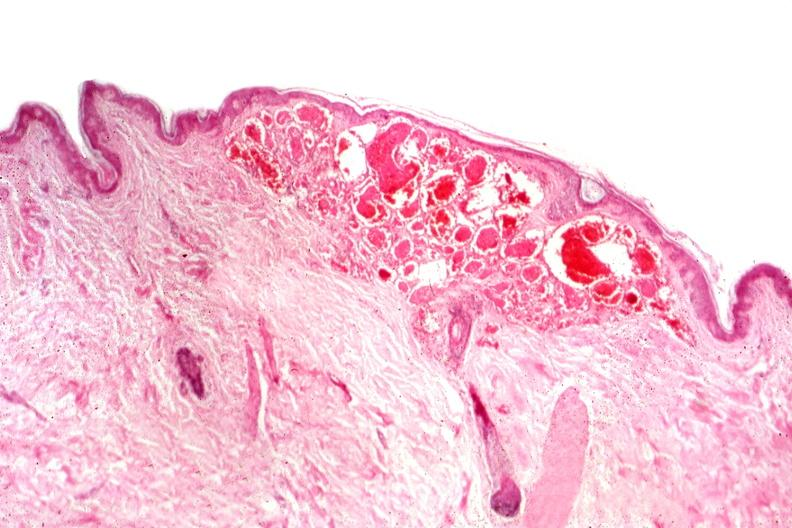what is present?
Answer the question using a single word or phrase. Hemangioma 